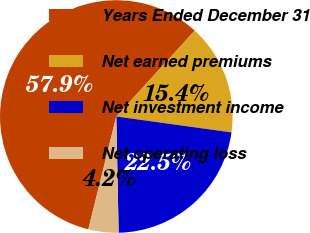Convert chart. <chart><loc_0><loc_0><loc_500><loc_500><pie_chart><fcel>Years Ended December 31<fcel>Net earned premiums<fcel>Net investment income<fcel>Net operating loss<nl><fcel>57.91%<fcel>15.4%<fcel>22.49%<fcel>4.19%<nl></chart> 